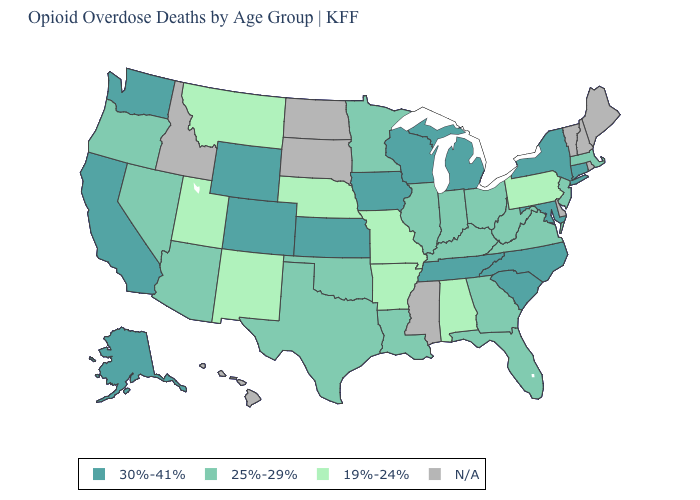Does the map have missing data?
Answer briefly. Yes. Which states hav the highest value in the South?
Quick response, please. Maryland, North Carolina, South Carolina, Tennessee. What is the value of Utah?
Be succinct. 19%-24%. What is the value of New Mexico?
Keep it brief. 19%-24%. Name the states that have a value in the range 30%-41%?
Concise answer only. Alaska, California, Colorado, Connecticut, Iowa, Kansas, Maryland, Michigan, New York, North Carolina, South Carolina, Tennessee, Washington, Wisconsin, Wyoming. What is the lowest value in states that border West Virginia?
Quick response, please. 19%-24%. What is the lowest value in the South?
Keep it brief. 19%-24%. What is the lowest value in the USA?
Be succinct. 19%-24%. What is the highest value in the USA?
Concise answer only. 30%-41%. What is the value of Nebraska?
Answer briefly. 19%-24%. Name the states that have a value in the range 30%-41%?
Quick response, please. Alaska, California, Colorado, Connecticut, Iowa, Kansas, Maryland, Michigan, New York, North Carolina, South Carolina, Tennessee, Washington, Wisconsin, Wyoming. Among the states that border Oregon , does Washington have the lowest value?
Short answer required. No. Name the states that have a value in the range 19%-24%?
Write a very short answer. Alabama, Arkansas, Missouri, Montana, Nebraska, New Mexico, Pennsylvania, Utah. Name the states that have a value in the range 30%-41%?
Be succinct. Alaska, California, Colorado, Connecticut, Iowa, Kansas, Maryland, Michigan, New York, North Carolina, South Carolina, Tennessee, Washington, Wisconsin, Wyoming. Which states have the lowest value in the MidWest?
Short answer required. Missouri, Nebraska. 